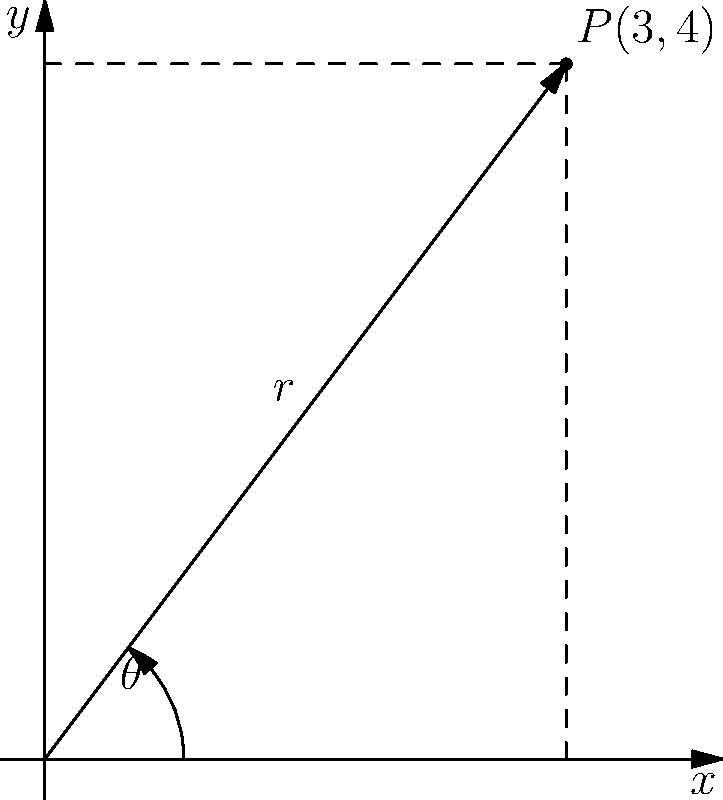In a custom wxWidgets polar plot widget, you need to convert Cartesian coordinates to polar coordinates. Given the point $P(3,4)$ in Cartesian coordinates, calculate its polar coordinates $(r,\theta)$. Express $\theta$ in radians, rounded to two decimal places. To convert from Cartesian coordinates $(x,y)$ to polar coordinates $(r,\theta)$, we use the following formulas:

1. For the radius $r$:
   $$r = \sqrt{x^2 + y^2}$$

2. For the angle $\theta$:
   $$\theta = \tan^{-1}\left(\frac{y}{x}\right)$$

Let's calculate step by step:

1. Calculate $r$:
   $$r = \sqrt{3^2 + 4^2} = \sqrt{9 + 16} = \sqrt{25} = 5$$

2. Calculate $\theta$:
   $$\theta = \tan^{-1}\left(\frac{4}{3}\right) \approx 0.9272952180$$

3. Round $\theta$ to two decimal places:
   $$\theta \approx 0.93 \text{ radians}$$

Therefore, the polar coordinates of $P(3,4)$ are $(5, 0.93)$.
Answer: $(5, 0.93)$ 